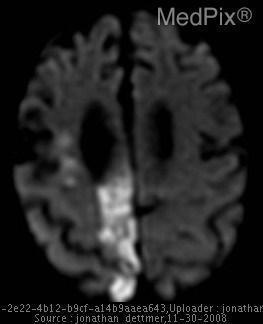Is the abnormality hyper intense?
Be succinct. Yes. Is the brain tissue ischemic?
Keep it brief. Yes. Is there atrophy of the brain?
Write a very short answer. Yes. Which hemisphere is the ischemia located?
Concise answer only. Right hemisphere. Where is the abnormality?
Answer briefly. Right pca. What does the abnormality suggest?
Be succinct. Ischemia. What causes the hyperintensity?
Give a very brief answer. Ischemia. 